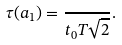<formula> <loc_0><loc_0><loc_500><loc_500>\tau ( a _ { 1 } ) = \frac { } { t _ { 0 } T \sqrt { 2 } } .</formula> 